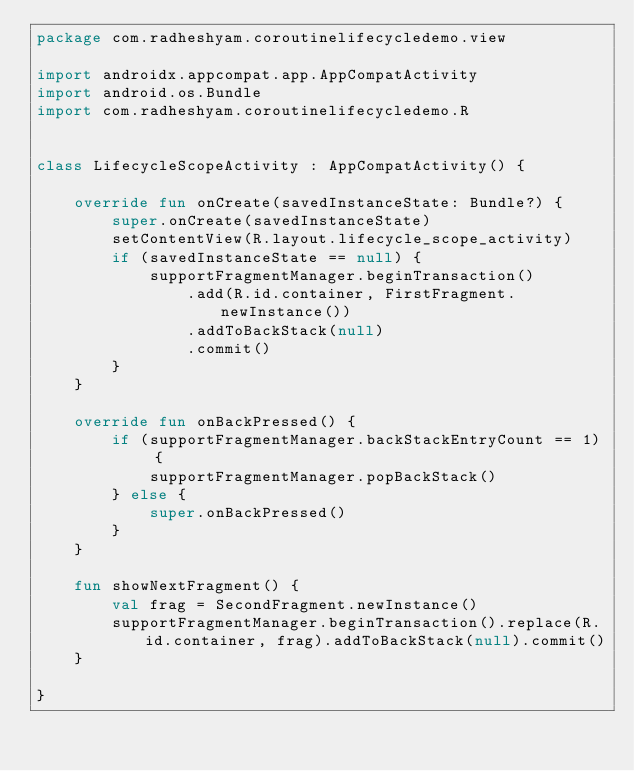Convert code to text. <code><loc_0><loc_0><loc_500><loc_500><_Kotlin_>package com.radheshyam.coroutinelifecycledemo.view

import androidx.appcompat.app.AppCompatActivity
import android.os.Bundle
import com.radheshyam.coroutinelifecycledemo.R


class LifecycleScopeActivity : AppCompatActivity() {

    override fun onCreate(savedInstanceState: Bundle?) {
        super.onCreate(savedInstanceState)
        setContentView(R.layout.lifecycle_scope_activity)
        if (savedInstanceState == null) {
            supportFragmentManager.beginTransaction()
                .add(R.id.container, FirstFragment.newInstance())
                .addToBackStack(null)
                .commit()
        }
    }

    override fun onBackPressed() {
        if (supportFragmentManager.backStackEntryCount == 1) {
            supportFragmentManager.popBackStack()
        } else {
            super.onBackPressed()
        }
    }

    fun showNextFragment() {
        val frag = SecondFragment.newInstance()
        supportFragmentManager.beginTransaction().replace(R.id.container, frag).addToBackStack(null).commit()
    }

}
</code> 